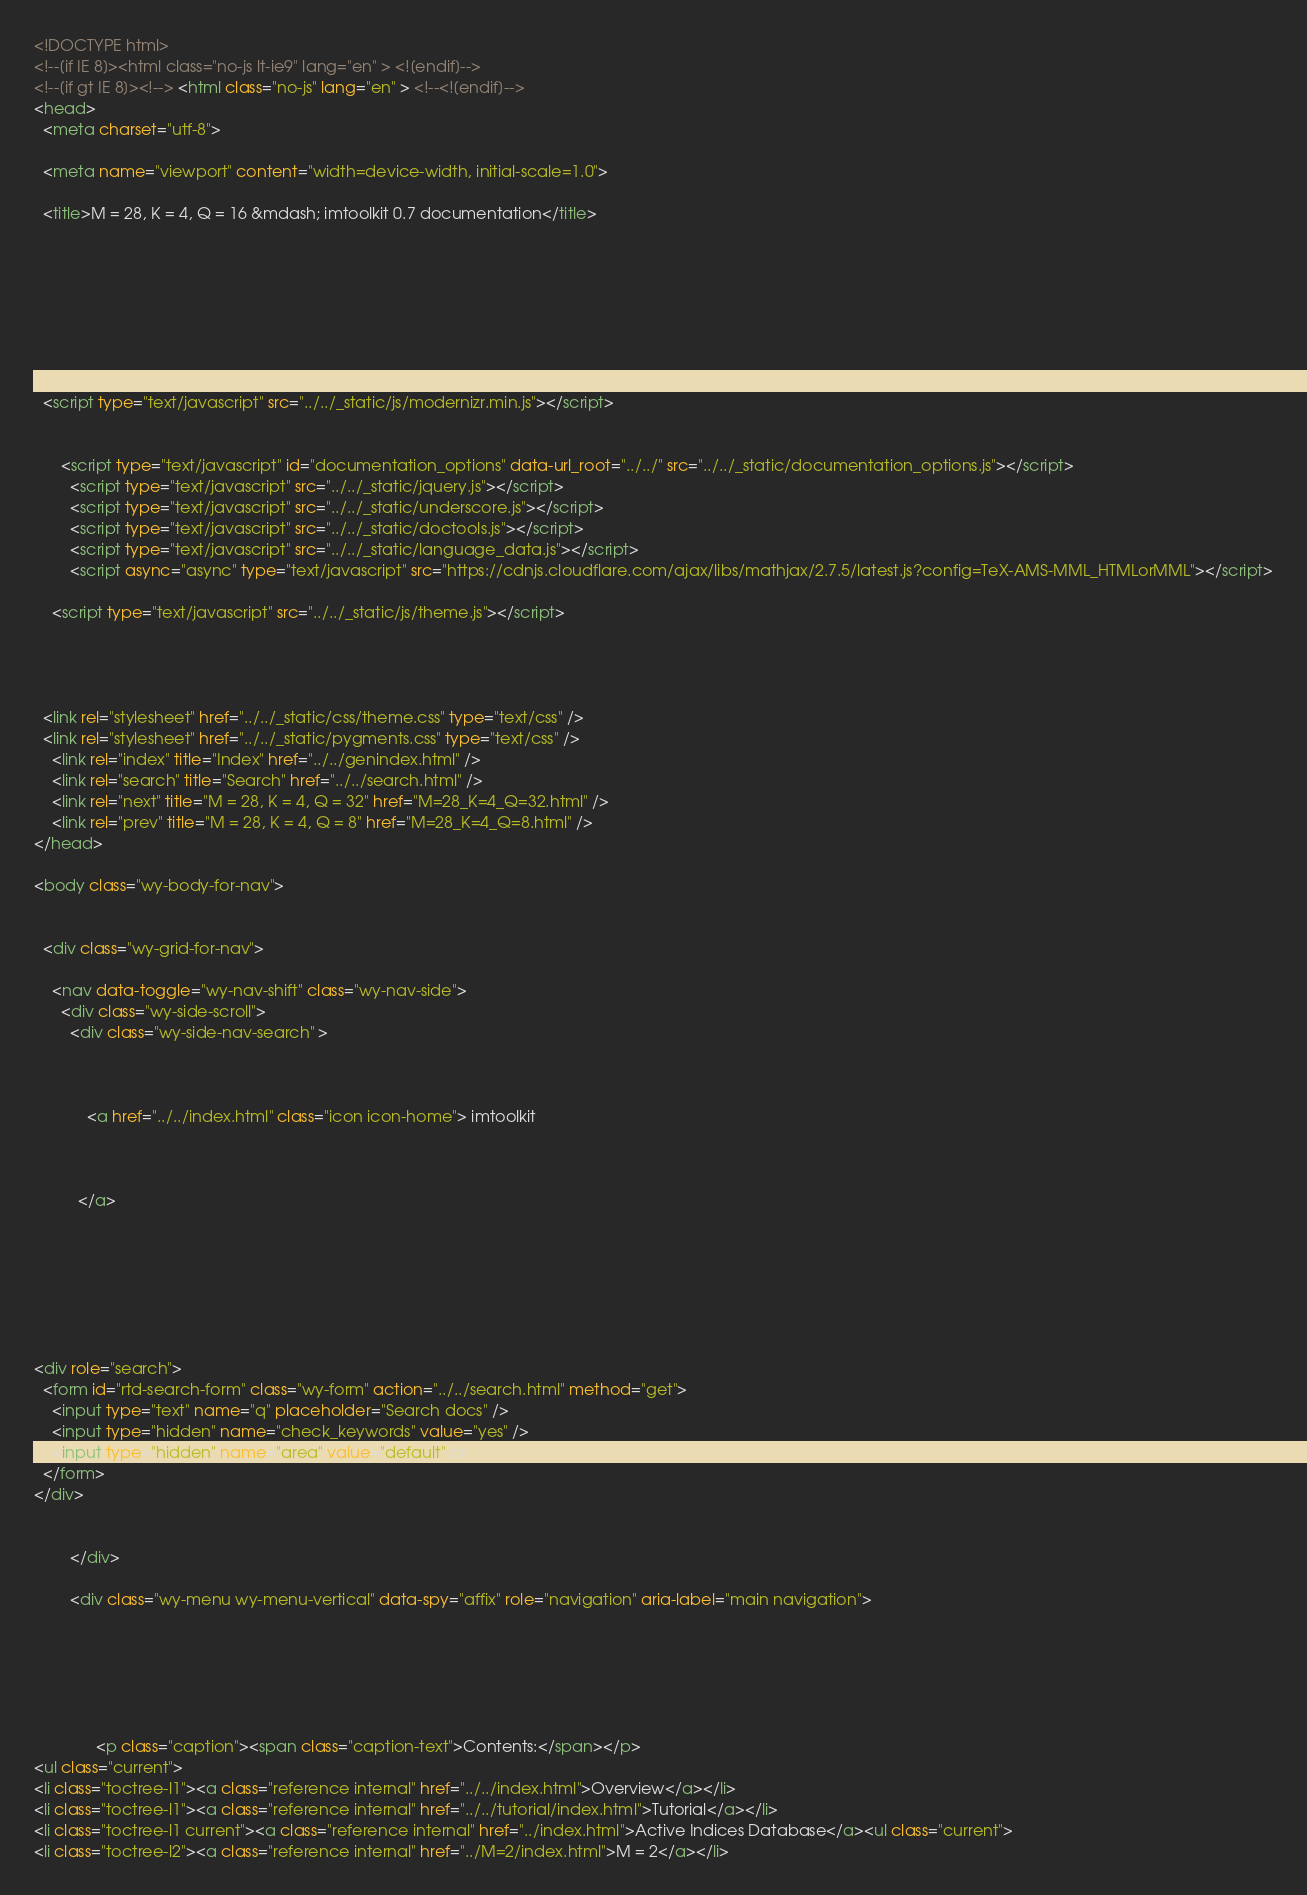<code> <loc_0><loc_0><loc_500><loc_500><_HTML_>

<!DOCTYPE html>
<!--[if IE 8]><html class="no-js lt-ie9" lang="en" > <![endif]-->
<!--[if gt IE 8]><!--> <html class="no-js" lang="en" > <!--<![endif]-->
<head>
  <meta charset="utf-8">
  
  <meta name="viewport" content="width=device-width, initial-scale=1.0">
  
  <title>M = 28, K = 4, Q = 16 &mdash; imtoolkit 0.7 documentation</title>
  

  
  
  
  

  
  <script type="text/javascript" src="../../_static/js/modernizr.min.js"></script>
  
    
      <script type="text/javascript" id="documentation_options" data-url_root="../../" src="../../_static/documentation_options.js"></script>
        <script type="text/javascript" src="../../_static/jquery.js"></script>
        <script type="text/javascript" src="../../_static/underscore.js"></script>
        <script type="text/javascript" src="../../_static/doctools.js"></script>
        <script type="text/javascript" src="../../_static/language_data.js"></script>
        <script async="async" type="text/javascript" src="https://cdnjs.cloudflare.com/ajax/libs/mathjax/2.7.5/latest.js?config=TeX-AMS-MML_HTMLorMML"></script>
    
    <script type="text/javascript" src="../../_static/js/theme.js"></script>

    

  
  <link rel="stylesheet" href="../../_static/css/theme.css" type="text/css" />
  <link rel="stylesheet" href="../../_static/pygments.css" type="text/css" />
    <link rel="index" title="Index" href="../../genindex.html" />
    <link rel="search" title="Search" href="../../search.html" />
    <link rel="next" title="M = 28, K = 4, Q = 32" href="M=28_K=4_Q=32.html" />
    <link rel="prev" title="M = 28, K = 4, Q = 8" href="M=28_K=4_Q=8.html" /> 
</head>

<body class="wy-body-for-nav">

   
  <div class="wy-grid-for-nav">
    
    <nav data-toggle="wy-nav-shift" class="wy-nav-side">
      <div class="wy-side-scroll">
        <div class="wy-side-nav-search" >
          

          
            <a href="../../index.html" class="icon icon-home"> imtoolkit
          

          
          </a>

          
            
            
          

          
<div role="search">
  <form id="rtd-search-form" class="wy-form" action="../../search.html" method="get">
    <input type="text" name="q" placeholder="Search docs" />
    <input type="hidden" name="check_keywords" value="yes" />
    <input type="hidden" name="area" value="default" />
  </form>
</div>

          
        </div>

        <div class="wy-menu wy-menu-vertical" data-spy="affix" role="navigation" aria-label="main navigation">
          
            
            
              
            
            
              <p class="caption"><span class="caption-text">Contents:</span></p>
<ul class="current">
<li class="toctree-l1"><a class="reference internal" href="../../index.html">Overview</a></li>
<li class="toctree-l1"><a class="reference internal" href="../../tutorial/index.html">Tutorial</a></li>
<li class="toctree-l1 current"><a class="reference internal" href="../index.html">Active Indices Database</a><ul class="current">
<li class="toctree-l2"><a class="reference internal" href="../M=2/index.html">M = 2</a></li></code> 